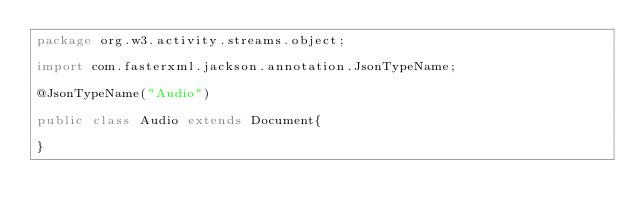Convert code to text. <code><loc_0><loc_0><loc_500><loc_500><_Java_>package org.w3.activity.streams.object;

import com.fasterxml.jackson.annotation.JsonTypeName;

@JsonTypeName("Audio")

public class Audio extends Document{

}
</code> 